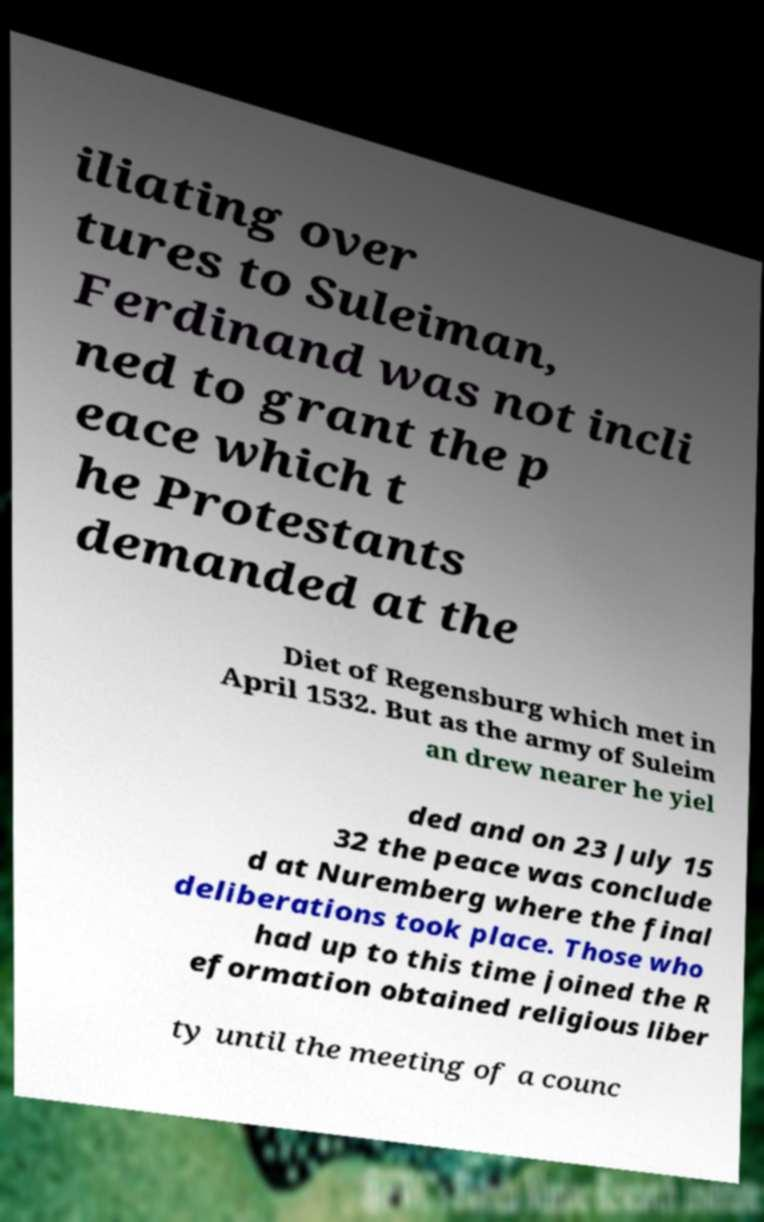What messages or text are displayed in this image? I need them in a readable, typed format. iliating over tures to Suleiman, Ferdinand was not incli ned to grant the p eace which t he Protestants demanded at the Diet of Regensburg which met in April 1532. But as the army of Suleim an drew nearer he yiel ded and on 23 July 15 32 the peace was conclude d at Nuremberg where the final deliberations took place. Those who had up to this time joined the R eformation obtained religious liber ty until the meeting of a counc 